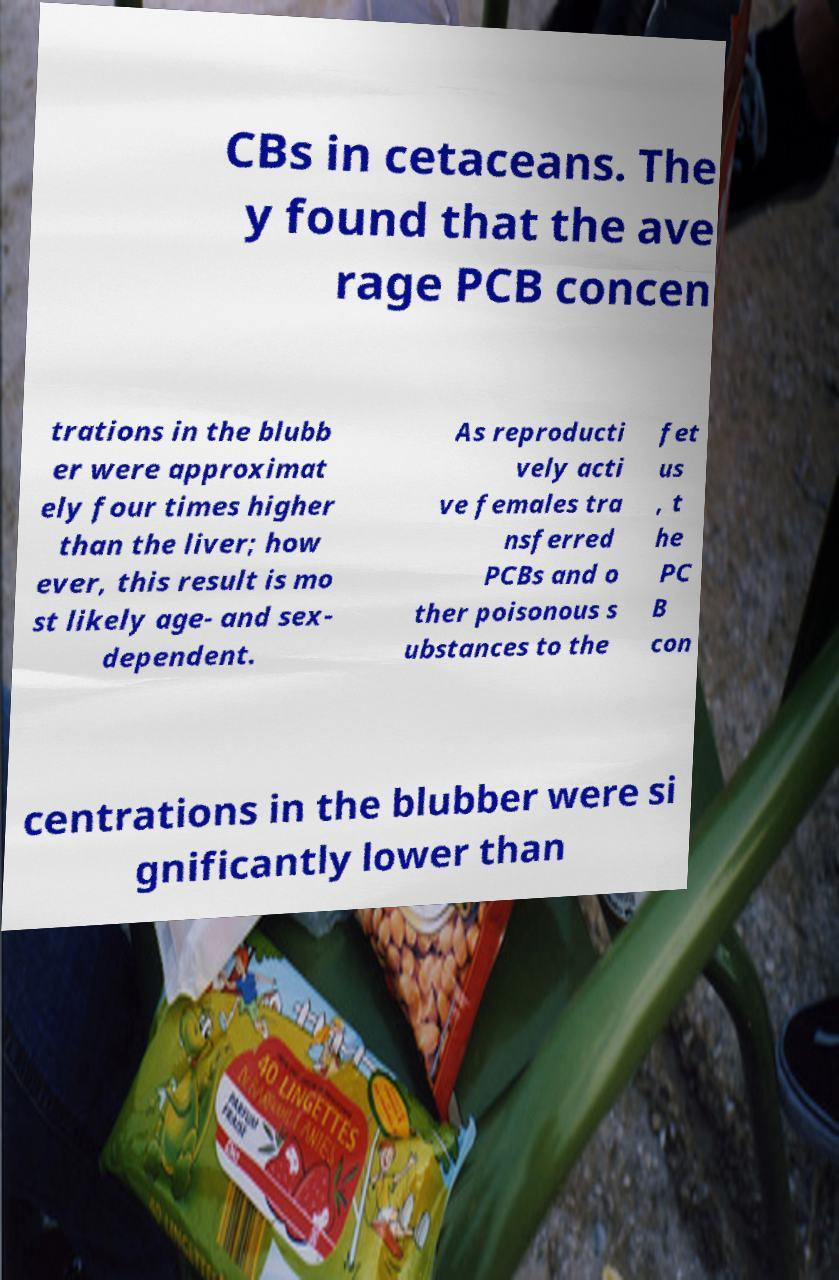Could you extract and type out the text from this image? CBs in cetaceans. The y found that the ave rage PCB concen trations in the blubb er were approximat ely four times higher than the liver; how ever, this result is mo st likely age- and sex- dependent. As reproducti vely acti ve females tra nsferred PCBs and o ther poisonous s ubstances to the fet us , t he PC B con centrations in the blubber were si gnificantly lower than 